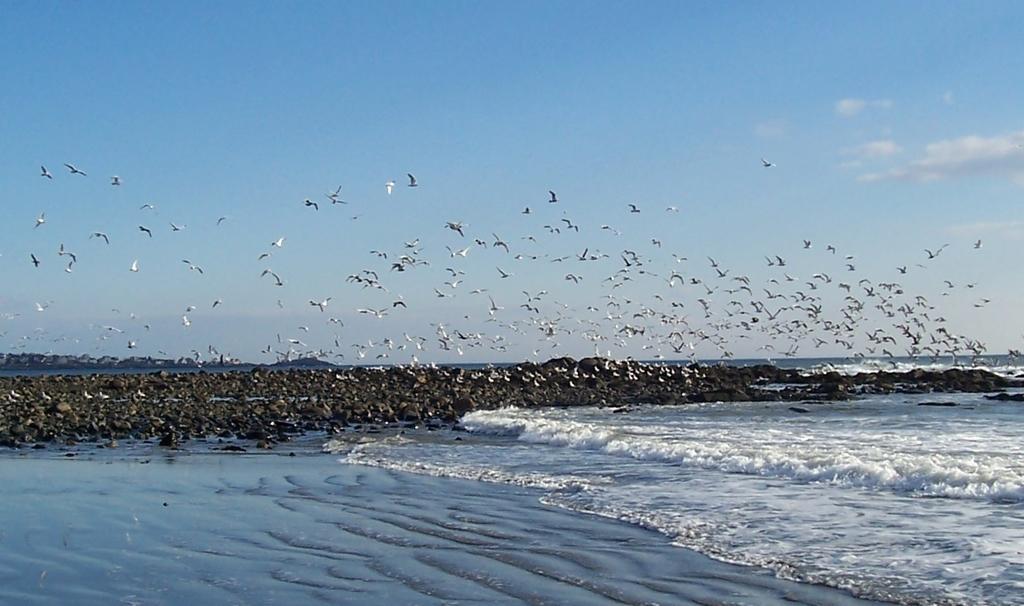Describe this image in one or two sentences. In the background we can see the sky. In this picture we can see the birds are flying. We can see the water and the rocks. 